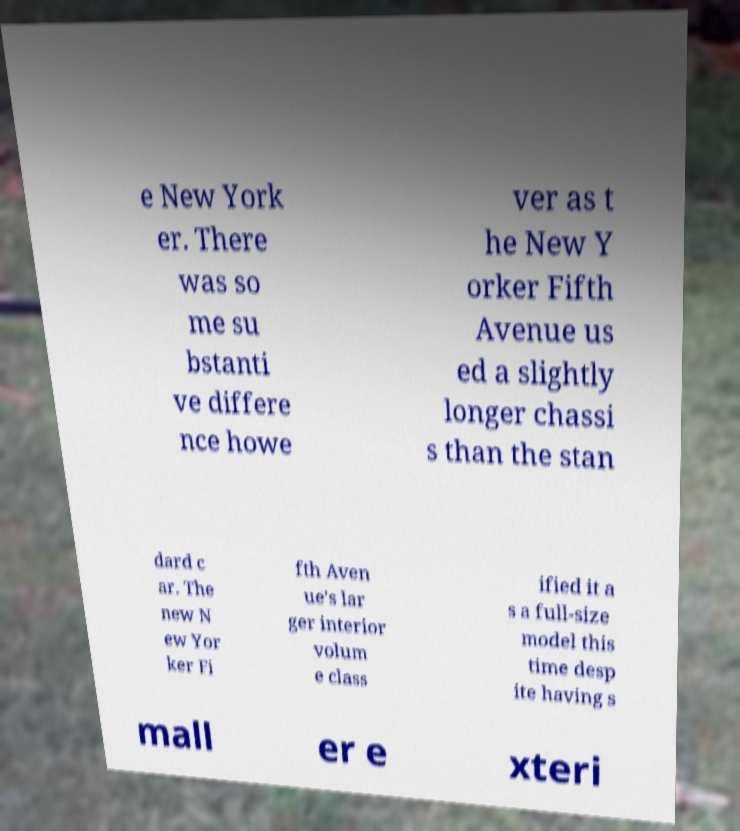Could you extract and type out the text from this image? e New York er. There was so me su bstanti ve differe nce howe ver as t he New Y orker Fifth Avenue us ed a slightly longer chassi s than the stan dard c ar. The new N ew Yor ker Fi fth Aven ue's lar ger interior volum e class ified it a s a full-size model this time desp ite having s mall er e xteri 